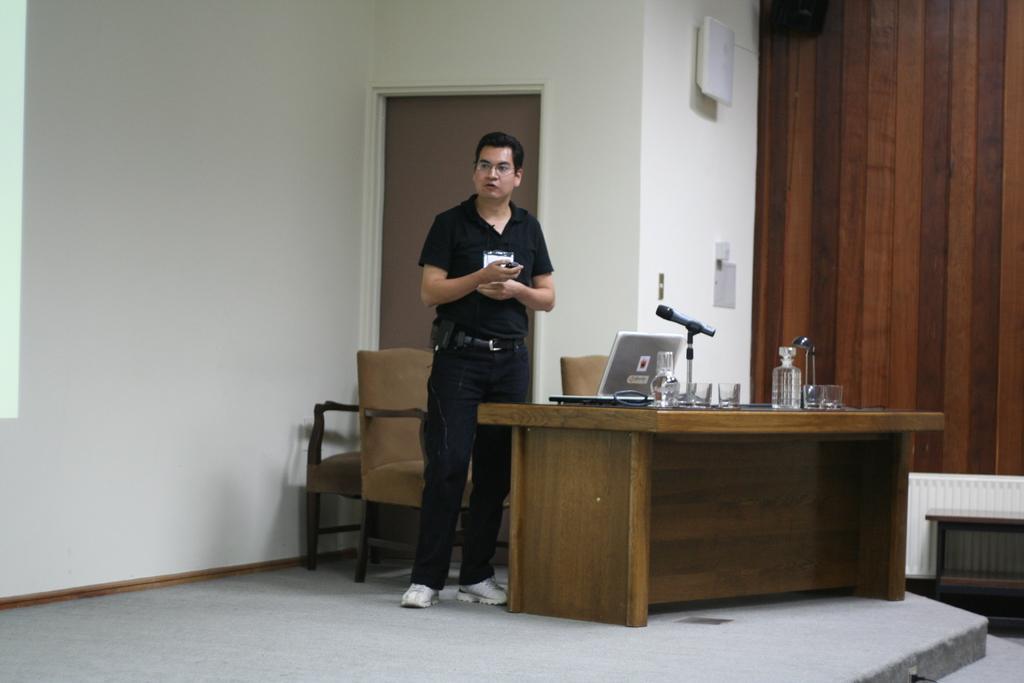Could you give a brief overview of what you see in this image? In this image i can see a man standing, there is a laptop , microphone, bottle on the table, at the back ground i can see a chair, wall and a paper. 